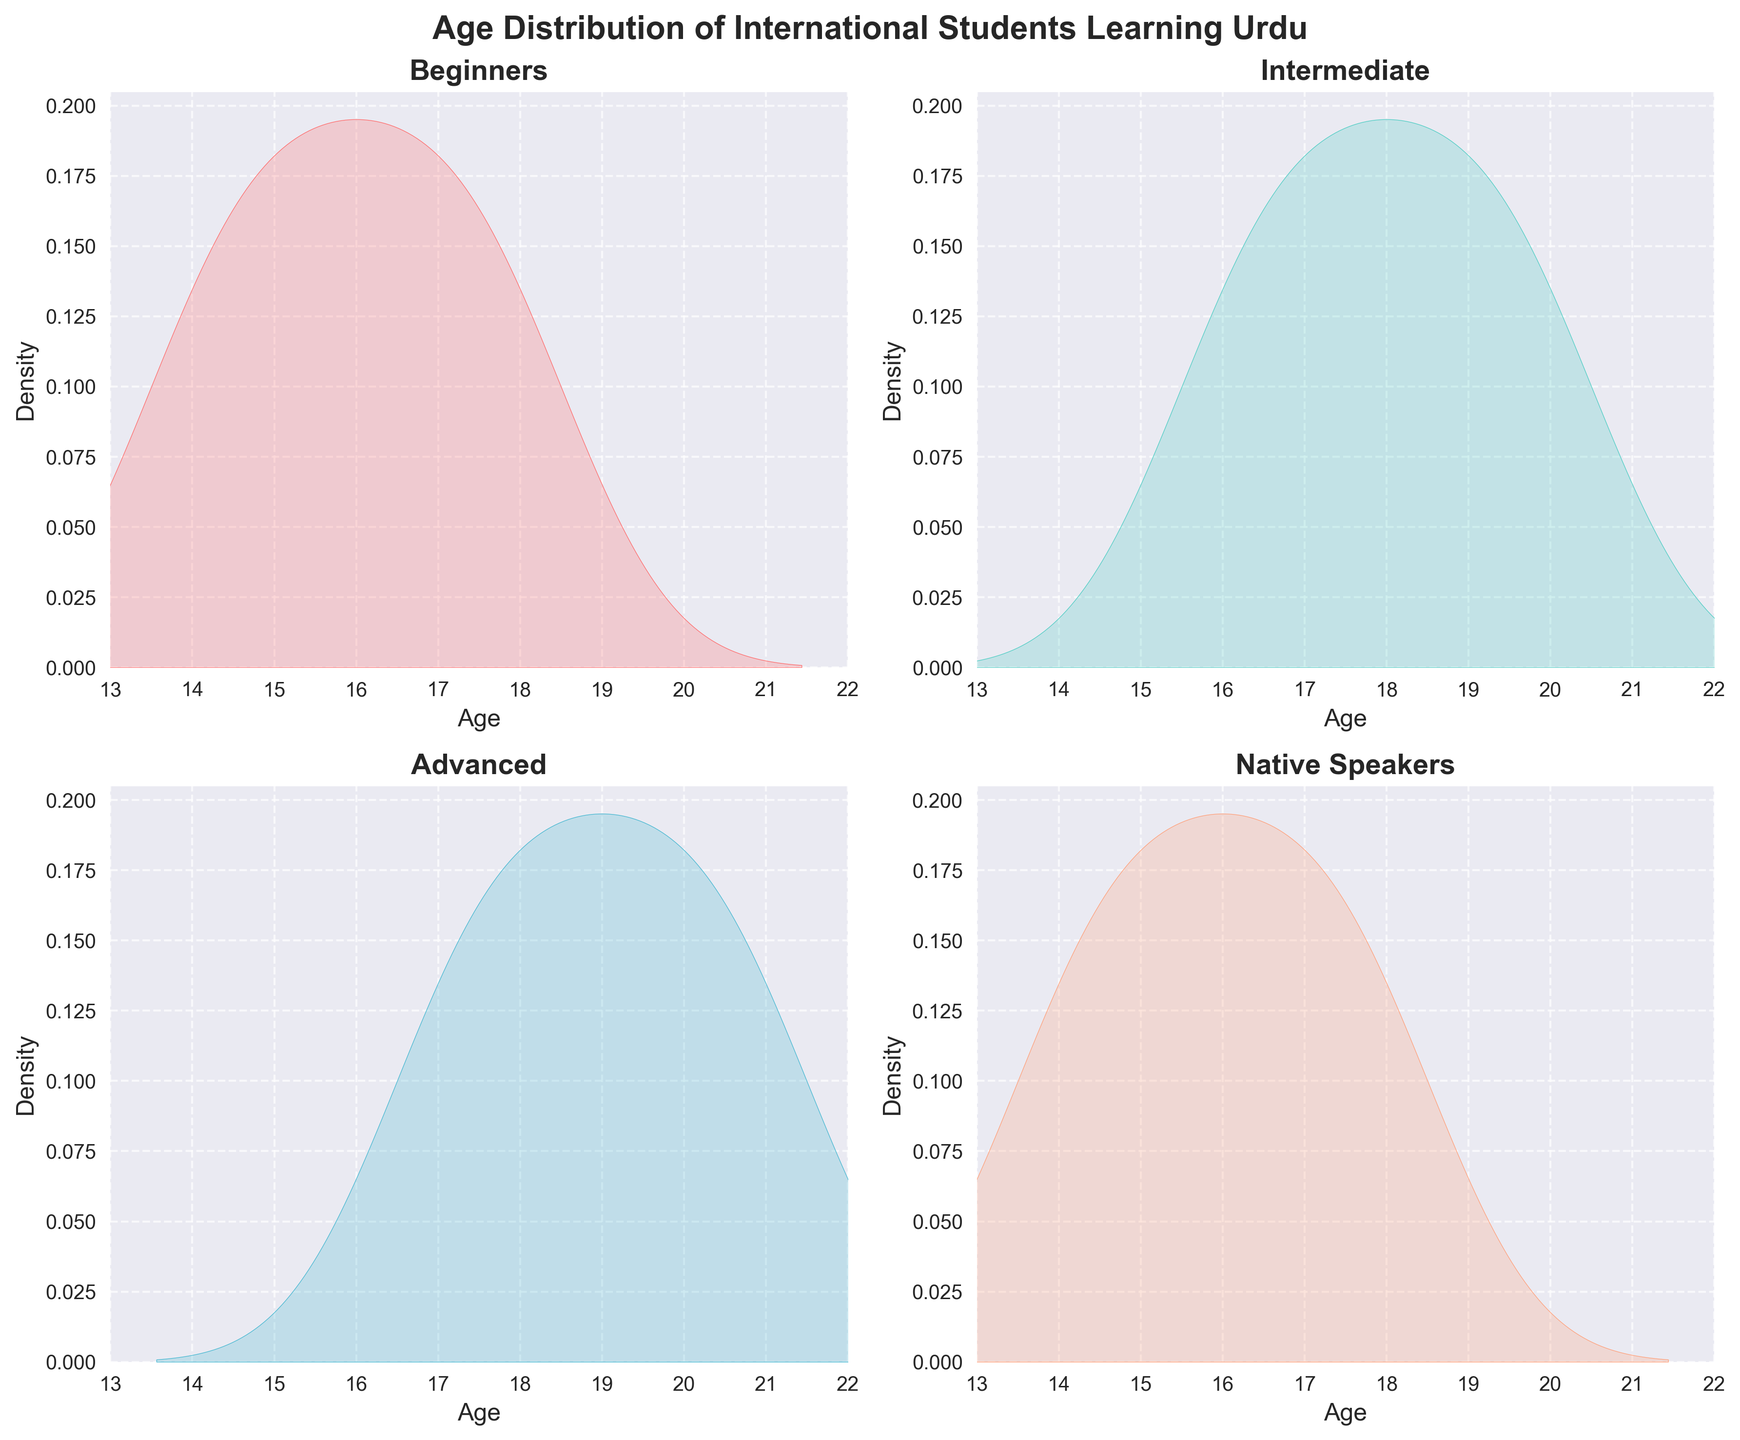What is the title of the figure? The title is typically shown at the top of the figure, which summarizes the main idea or subject of the plot. In this case, the title should be 'Age Distribution of International Students Learning Urdu'.
Answer: Age Distribution of International Students Learning Urdu How many subplots are there in the figure? Subplots are smaller plots within a main plot. By observing the layout, you can count the number of individual density plots. Each category (Beginners, Intermediate, Advanced, Native Speakers) has its own subplot.
Answer: 4 What is the age range considered in these density plots? The range of ages can be observed along the x-axis of the subplots, marked from the minimum to maximum values. The x-axis labels indicate the ages considered.
Answer: 13 to 22 Which category shows the highest density peak in the age distribution? Density peaks indicate the age at which the density of students is highest for a given category. By comparing the peaks of the density curves in each subplot, we can identify which one is the highest.
Answer: Beginners What is the primary color used for the 'Intermediate' category density plot? The primary color used in a subplot can be identified by looking at the specific category's density curve. For 'Intermediate', the specified color is visually distinctive.
Answer: Green In which category do students show the most uniform age distribution? A uniform age distribution means that the density plot should be relatively flat across the age range. By observing the shapes of the density curves, one can figure out which category displays the most even distribution.
Answer: Native Speakers What age is the most common among advanced students? The most common age can be determined by looking at the peak of the density plot for the 'Advanced' category. The highest point on this curve indicates the most frequent age.
Answer: 17 Compare the age distributions of 'Beginners' and 'Intermediate' categories: which category shows a wider spread of ages? To determine the spread, observe the width of the density plots for each category. A wider spread means the ages are more varied within that category. Compare the width of the density plots for 'Beginners' and 'Intermediate'.
Answer: Intermediate What is the age distribution pattern for 'Native Speakers'? The pattern can be described by the shape and spread of the density plot. For 'Native Speakers', observe how the age densities are distributed across the range and any notable peaks or flatness.
Answer: Relatively uniform Which category has a peak at the age of 19? A peak at a specific age means that age is the most common within that category. By examining the subplots and focusing on the density curves, you can identify the category with a noticeable peak at age 19.
Answer: Intermediate 